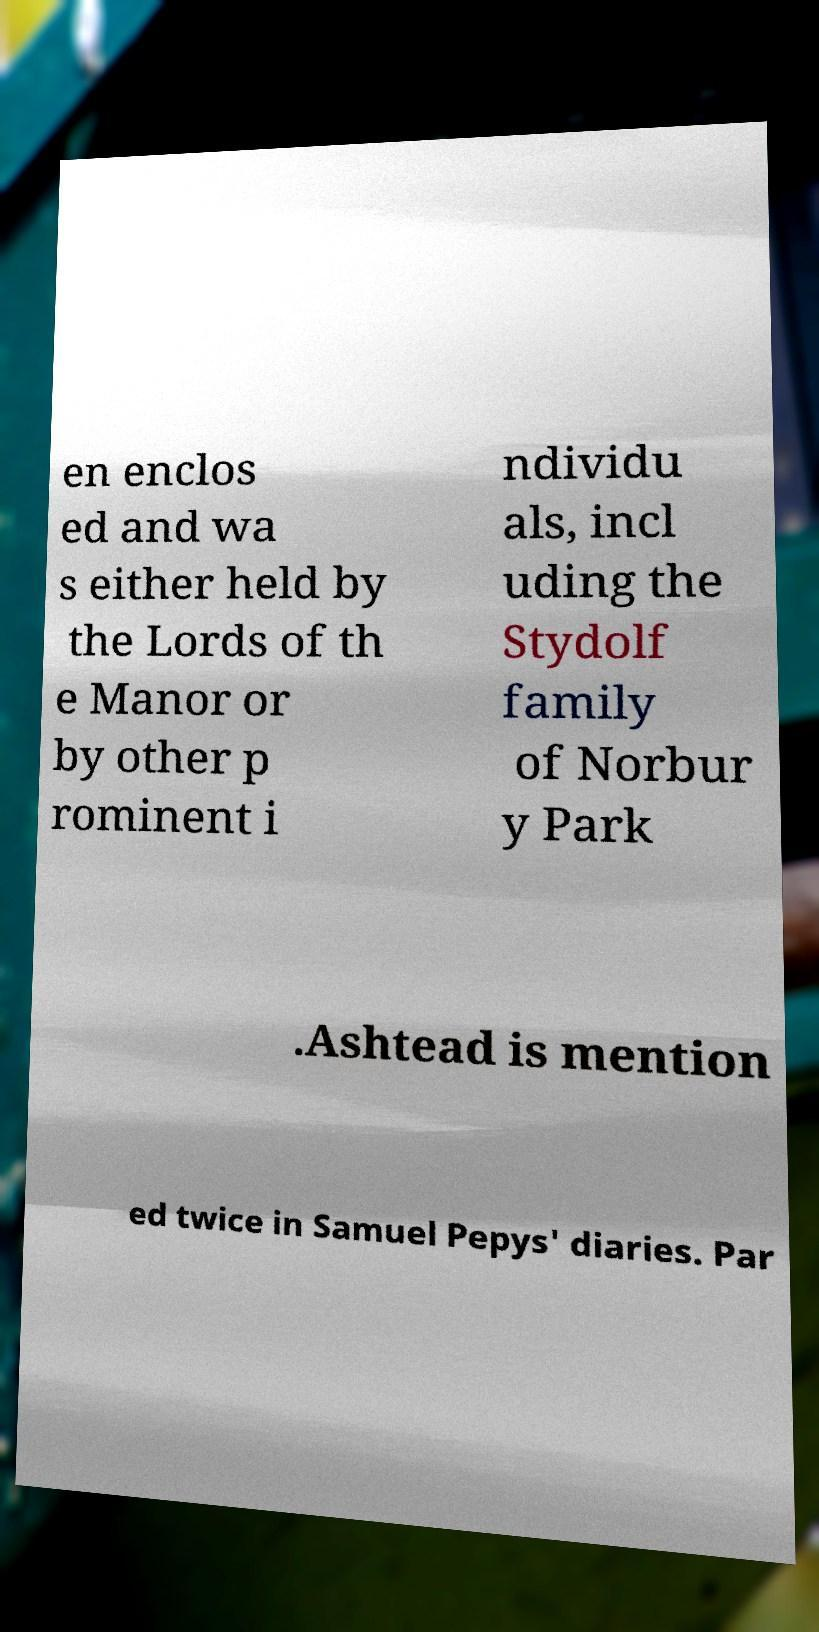What messages or text are displayed in this image? I need them in a readable, typed format. en enclos ed and wa s either held by the Lords of th e Manor or by other p rominent i ndividu als, incl uding the Stydolf family of Norbur y Park .Ashtead is mention ed twice in Samuel Pepys' diaries. Par 